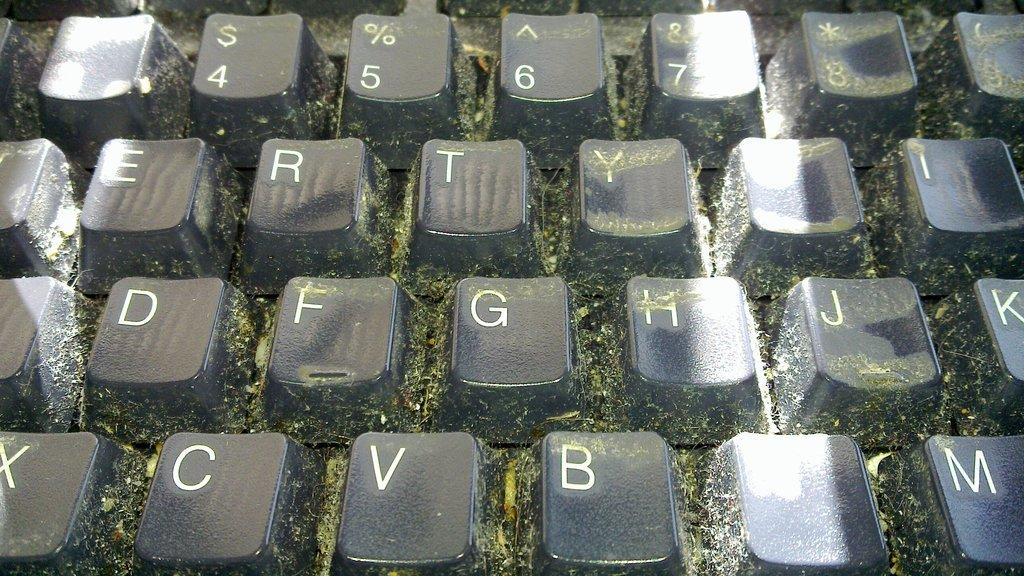Provide a one-sentence caption for the provided image. A computer keyboard with keys containing letters such as e, r and t. 